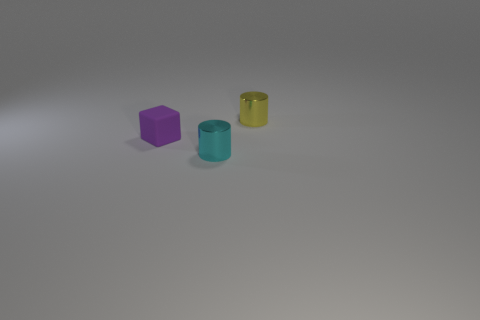What is the object that is on the left side of the metal cylinder in front of the tiny purple thing made of?
Offer a very short reply. Rubber. What number of things are either small cyan metallic cylinders or small shiny objects behind the small purple cube?
Keep it short and to the point. 2. Are there more yellow shiny objects that are in front of the small rubber block than shiny things?
Provide a short and direct response. No. There is a object that is in front of the tiny yellow metallic object and behind the small cyan metal thing; what is its size?
Your answer should be compact. Small. What material is the cyan thing that is the same shape as the tiny yellow metal object?
Offer a terse response. Metal. Do the shiny object to the left of the yellow metallic object and the yellow shiny thing have the same size?
Provide a succinct answer. Yes. The object that is both behind the tiny cyan cylinder and on the right side of the rubber thing is what color?
Provide a succinct answer. Yellow. There is a cylinder that is on the left side of the tiny yellow metal object; what number of tiny cylinders are right of it?
Offer a very short reply. 1. Is the shape of the tiny rubber object the same as the yellow shiny thing?
Give a very brief answer. No. Is the shape of the tiny cyan metallic thing the same as the tiny purple thing behind the tiny cyan cylinder?
Make the answer very short. No. 